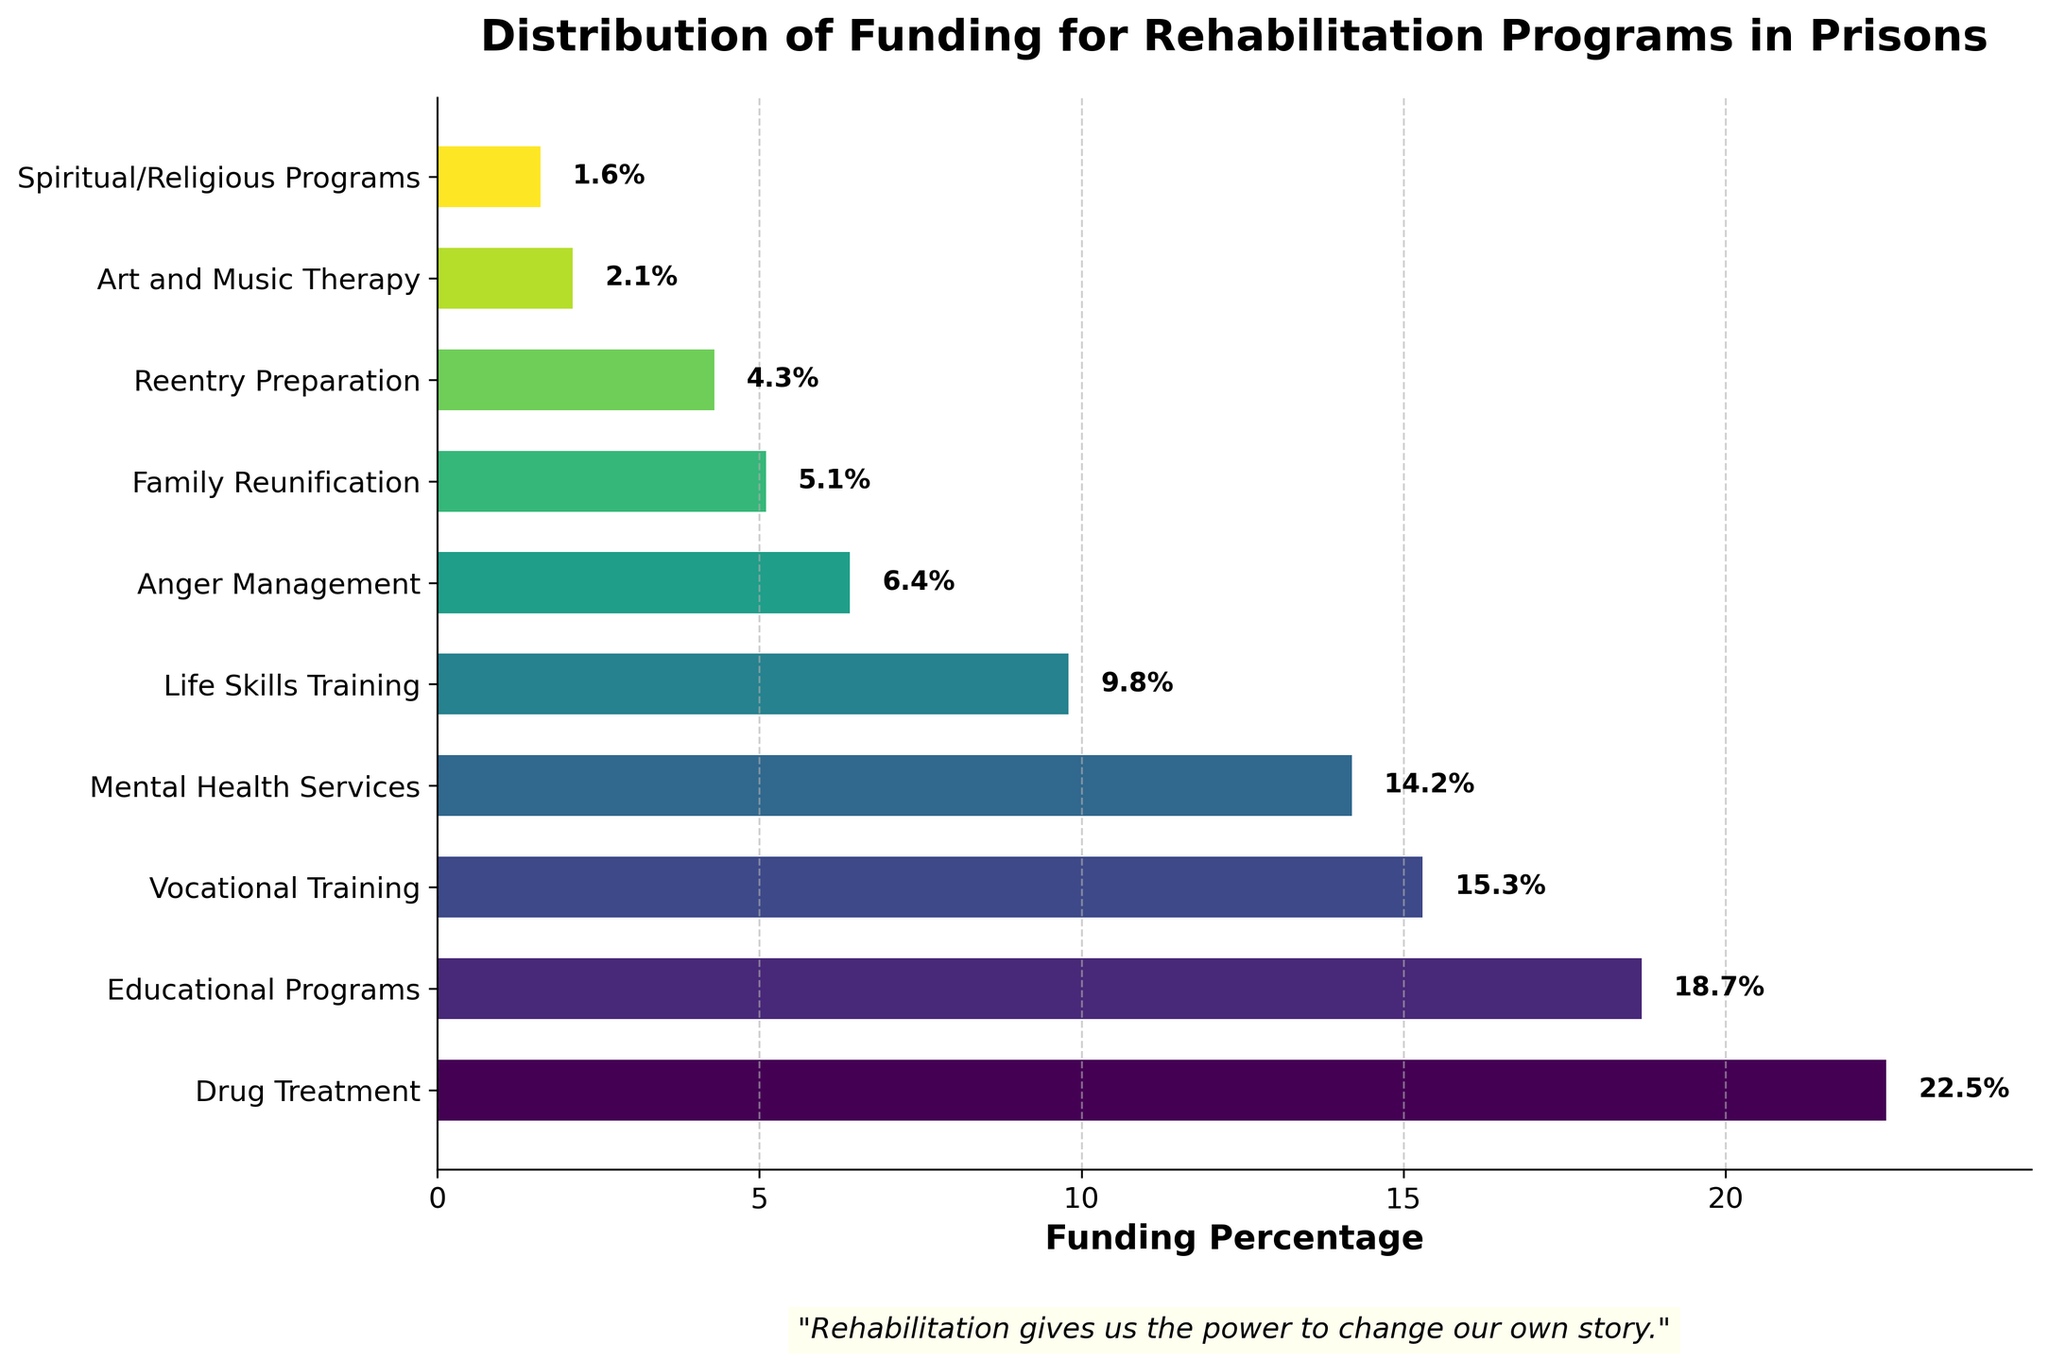What is the program with the highest percentage of funding? The bar chart shows that Drug Treatment has the highest percentage of funding at 22.5%.
Answer: Drug Treatment How much more funding does Drug Treatment receive compared to Anger Management? Drug Treatment receives 22.5% and Anger Management receives 6.4%. The difference is 22.5% - 6.4% = 16.1%.
Answer: 16.1% Which program receives the least amount of funding? The bar for Spiritual/Religious Programs is the shortest, indicating that it receives the least funding at 1.6%.
Answer: Spiritual/Religious Programs What is the combined funding percentage for Educational Programs and Vocational Training? Educational Programs receive 18.7% and Vocational Training receives 15.3%. Combined, they receive 18.7% + 15.3% = 34.0%.
Answer: 34.0% Is the funding for Life Skills Training more than or less than that for Mental Health Services? Life Skills Training receives 9.8% and Mental Health Services receives 14.2%, so Life Skills Training receives less funding.
Answer: Less Which two programs are closest in funding percentage? Anger Management and Family Reunification are closest, with 6.4% and 5.1% respectively. The difference is 6.4% - 5.1% = 1.3%.
Answer: Anger Management and Family Reunification What is the total funding percentage for all programs with less than 10% funding? The programs below 10% are Life Skills Training (9.8%), Anger Management (6.4%), Family Reunification (5.1%), Reentry Preparation (4.3%), Art and Music Therapy (2.1%), and Spiritual/Religious Programs (1.6%). The total is 9.8 + 6.4 + 5.1 + 4.3 + 2.1 + 1.6 = 29.3%.
Answer: 29.3% How much more funding does Mental Health Services receive compared to Reentry Preparation? Mental Health Services receives 14.2% and Reentry Preparation receives 4.3%. The difference is 14.2% - 4.3% = 9.9%.
Answer: 9.9% Which program has a funding percentage closest to 5%? Family Reunification is the closest to 5% with a funding percentage of 5.1%.
Answer: Family Reunification What is the average funding percentage for the top four funded programs? The top four programs are Drug Treatment (22.5%), Educational Programs (18.7%), Vocational Training (15.3%), and Mental Health Services (14.2%). The average is (22.5 + 18.7 + 15.3 + 14.2) / 4 = 17.675%.
Answer: 17.675% 